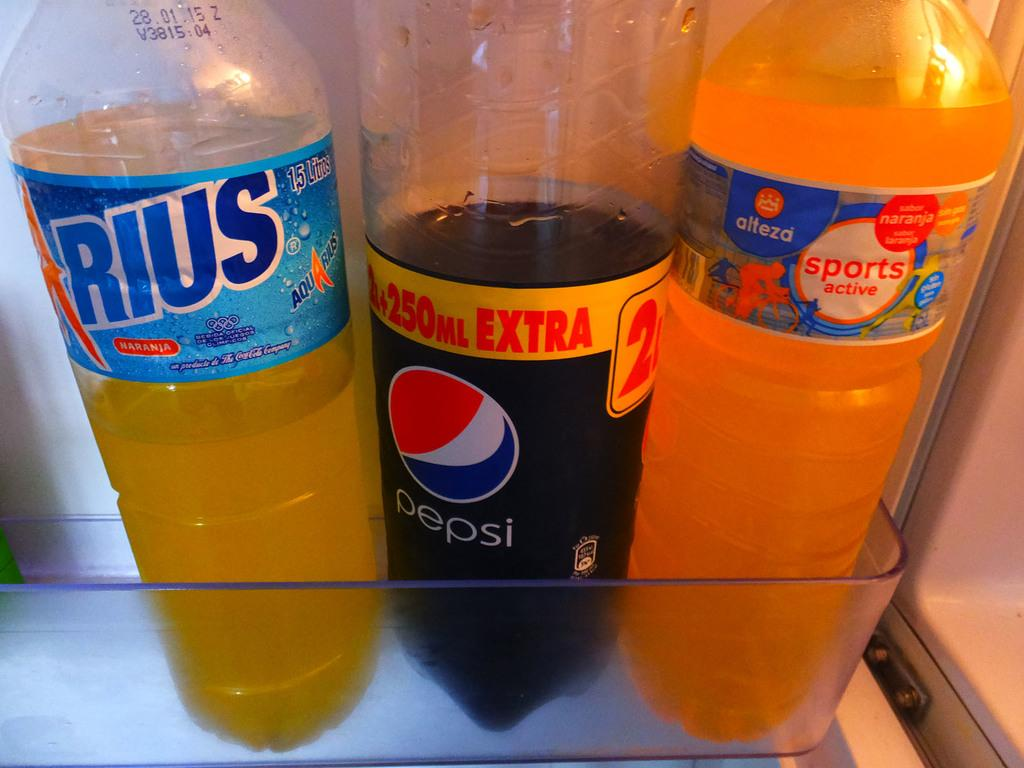How many bottles are visible in the image? There are three bottles in the image. What type of meat is being exchanged between the bottles in the image? There is no meat or exchange of any kind present in the image; it only features three bottles. 